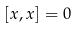<formula> <loc_0><loc_0><loc_500><loc_500>[ x , x ] = 0</formula> 